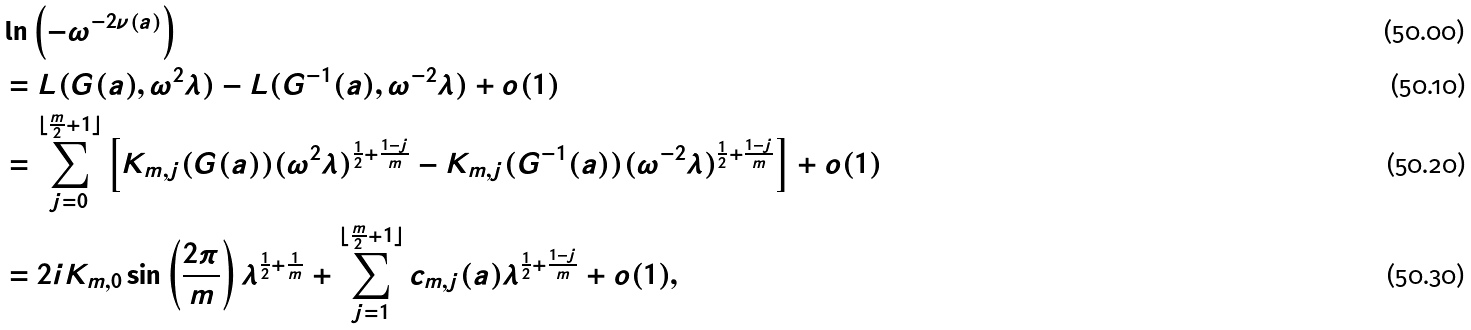<formula> <loc_0><loc_0><loc_500><loc_500>& \ln \left ( - \omega ^ { - 2 \nu ( a ) } \right ) \\ & = L ( G ( a ) , \omega ^ { 2 } \lambda ) - L ( G ^ { - 1 } ( a ) , \omega ^ { - 2 } \lambda ) + o ( 1 ) \\ & = \sum _ { j = 0 } ^ { \lfloor \frac { m } { 2 } + 1 \rfloor } \left [ K _ { m , j } ( G ( a ) ) ( \omega ^ { 2 } \lambda ) ^ { \frac { 1 } { 2 } + \frac { 1 - j } { m } } - K _ { m , j } ( G ^ { - 1 } ( a ) ) ( \omega ^ { - 2 } \lambda ) ^ { \frac { 1 } { 2 } + \frac { 1 - j } { m } } \right ] + o ( 1 ) \\ & = 2 i K _ { m , 0 } \sin \left ( \frac { 2 \pi } { m } \right ) \lambda ^ { \frac { 1 } { 2 } + \frac { 1 } { m } } + \sum _ { j = 1 } ^ { \lfloor \frac { m } { 2 } + 1 \rfloor } c _ { m , j } ( a ) \lambda ^ { \frac { 1 } { 2 } + \frac { 1 - j } { m } } + o ( 1 ) ,</formula> 